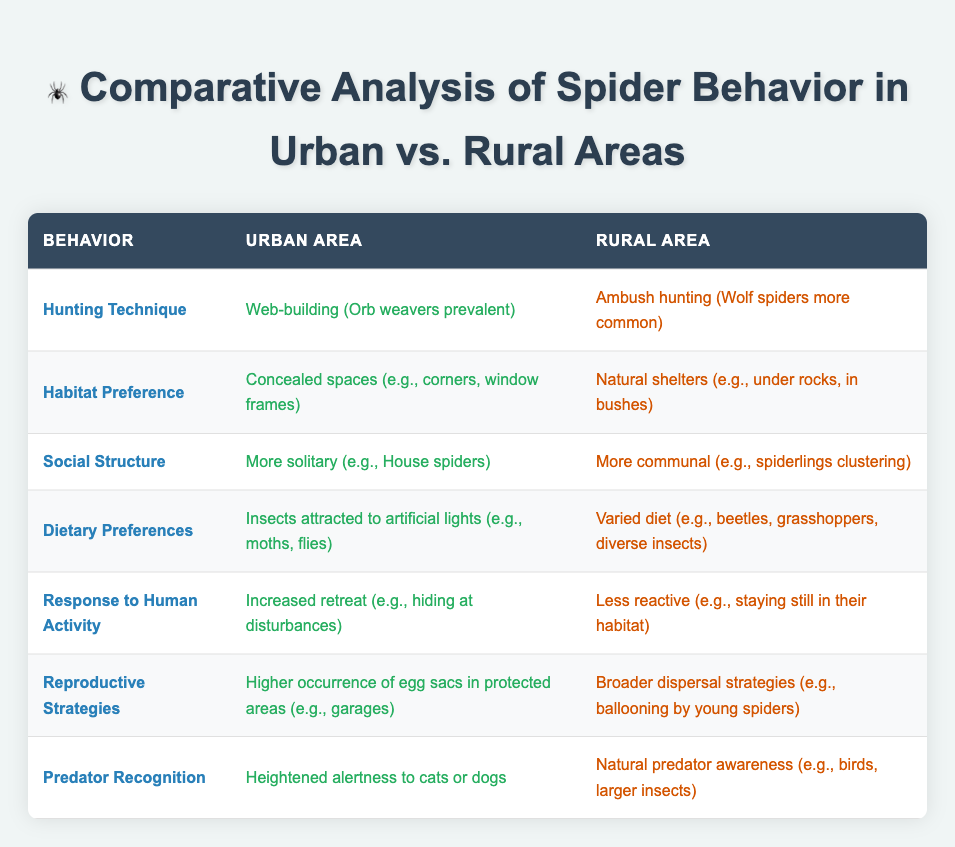What hunting technique do spiders use in urban areas? Referring to the table, the hunting technique for urban areas is identified as web-building, especially with orb weavers being prevalent.
Answer: Web-building (Orb weavers prevalent) Which social structure is more common in rural spiders compared to urban spiders? The table shows that rural spiders have a more communal social structure, exemplified by spiderlings clustering, while urban spiders tend to be more solitary.
Answer: More communal (e.g., spiderlings clustering) Do urban spiders have a greater dietary preference for insects attracted to artificial lights? According to the table, urban spiders indeed have a greater dietary preference for insects attracted to artificial lights such as moths and flies.
Answer: Yes In what type of shelter do urban spiders prefer to hide? The table specifies that urban spiders prefer concealed spaces like corners and window frames for shelter.
Answer: Concealed spaces (e.g., corners, window frames) What distinguishes the reproductive strategies of urban spiders from those in rural areas? The table indicates that urban spiders have a higher occurrence of egg sacs in protected areas, such as garages, while rural spiders employ broader dispersal strategies, like ballooning.
Answer: Higher occurrence of egg sacs in protected areas How does the response to human activity differ between urban and rural spiders? It is noted in the table that urban spiders show increased retreat or hiding when disturbed, while rural spiders are less reactive and tend to stay still in their habitats.
Answer: Increased retreat in urban areas What is the difference in predator recognition between urban and rural spiders? The urban spiders exhibit a heightened alertness to cats and dogs as predators, whereas rural spiders show a natural awareness of their predators, which include birds and larger insects, as indicated in the table.
Answer: Heightened alertness to cats or dogs How many behaviors are compared in the analysis? By counting the entries in the table, there are a total of 7 distinct behaviors compared between urban and rural spiders.
Answer: 7 behaviors Is it true that rural spiders tend to have a more varied diet than urban spiders? The table confirms this fact, as it indicates that rural spiders have a varied diet that includes beetles, grasshoppers, and diverse insects, while urban spiders primarily feed on insects attracted to lights.
Answer: Yes 